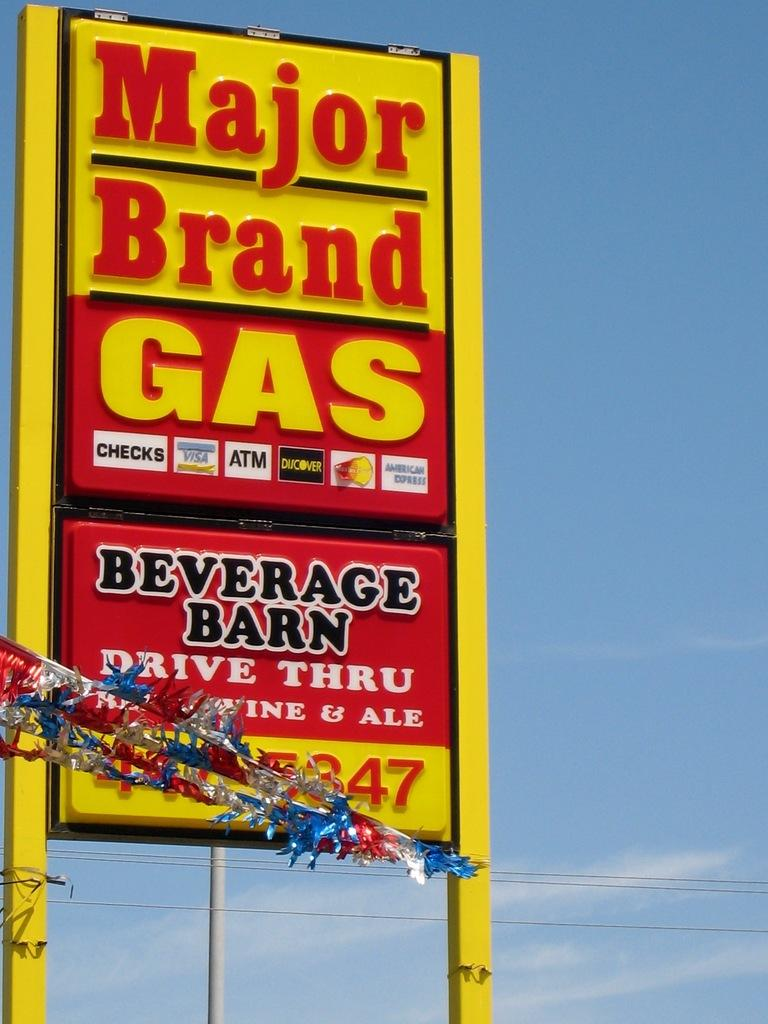<image>
Describe the image concisely. Yellow and red sign that says major brand gas. 